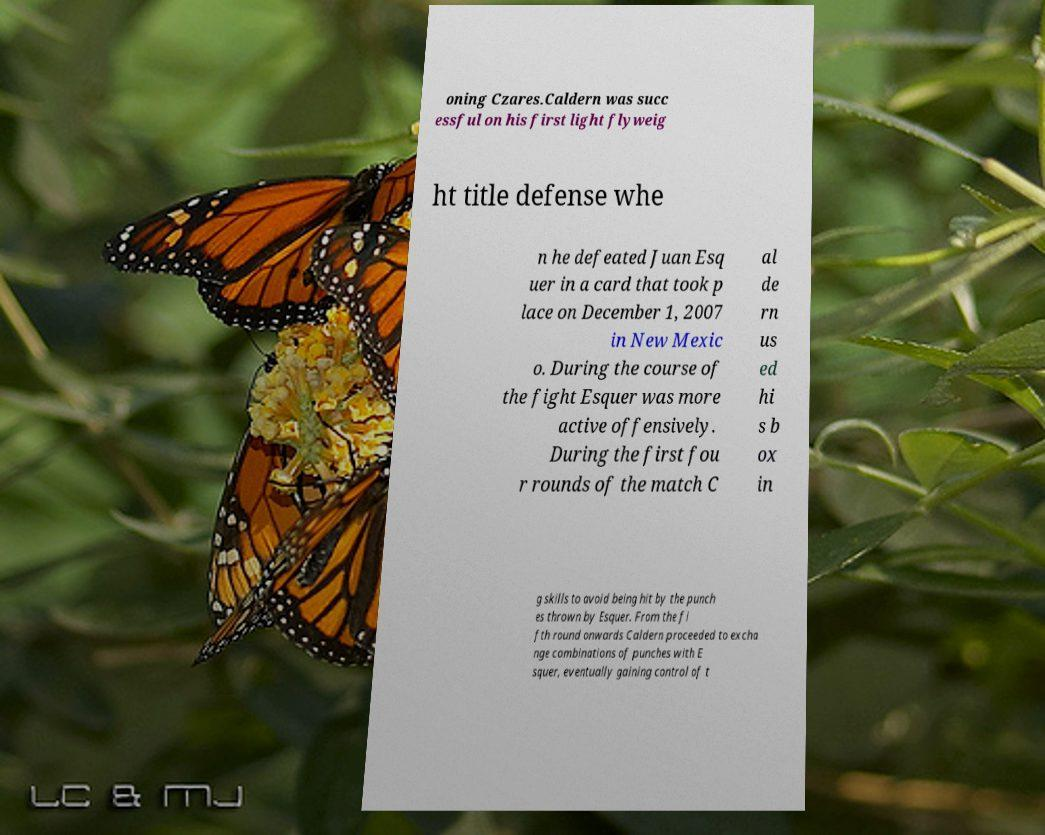What messages or text are displayed in this image? I need them in a readable, typed format. oning Czares.Caldern was succ essful on his first light flyweig ht title defense whe n he defeated Juan Esq uer in a card that took p lace on December 1, 2007 in New Mexic o. During the course of the fight Esquer was more active offensively. During the first fou r rounds of the match C al de rn us ed hi s b ox in g skills to avoid being hit by the punch es thrown by Esquer. From the fi fth round onwards Caldern proceeded to excha nge combinations of punches with E squer, eventually gaining control of t 